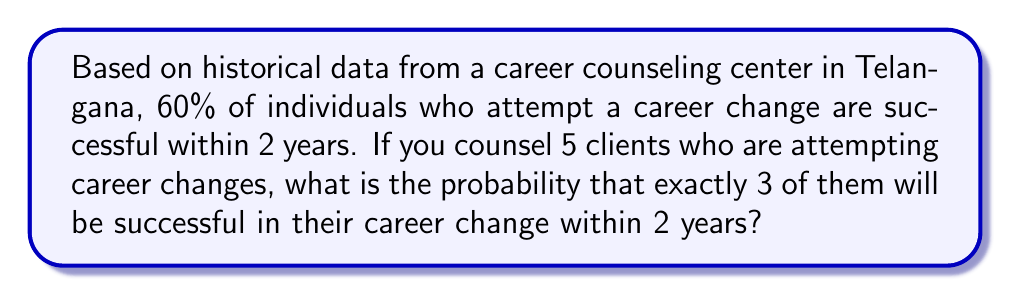Solve this math problem. To solve this problem, we need to use the binomial probability distribution, as we're dealing with a fixed number of independent trials (5 clients) with two possible outcomes (success or failure) and a constant probability of success.

Let's define our variables:
$n = 5$ (number of clients)
$k = 3$ (number of successful career changes we're interested in)
$p = 0.60$ (probability of success for each client)
$q = 1 - p = 0.40$ (probability of failure for each client)

The binomial probability formula is:

$$P(X = k) = \binom{n}{k} p^k q^{n-k}$$

Where $\binom{n}{k}$ is the binomial coefficient, calculated as:

$$\binom{n}{k} = \frac{n!}{k!(n-k)!}$$

Step 1: Calculate the binomial coefficient
$$\binom{5}{3} = \frac{5!}{3!(5-3)!} = \frac{5 \cdot 4 \cdot 3!}{3! \cdot 2 \cdot 1} = 10$$

Step 2: Apply the binomial probability formula
$$P(X = 3) = 10 \cdot (0.60)^3 \cdot (0.40)^{5-3}$$
$$P(X = 3) = 10 \cdot (0.60)^3 \cdot (0.40)^2$$
$$P(X = 3) = 10 \cdot 0.216 \cdot 0.16$$
$$P(X = 3) = 0.3456$$

Therefore, the probability of exactly 3 out of 5 clients being successful in their career change within 2 years is 0.3456 or 34.56%.
Answer: 0.3456 